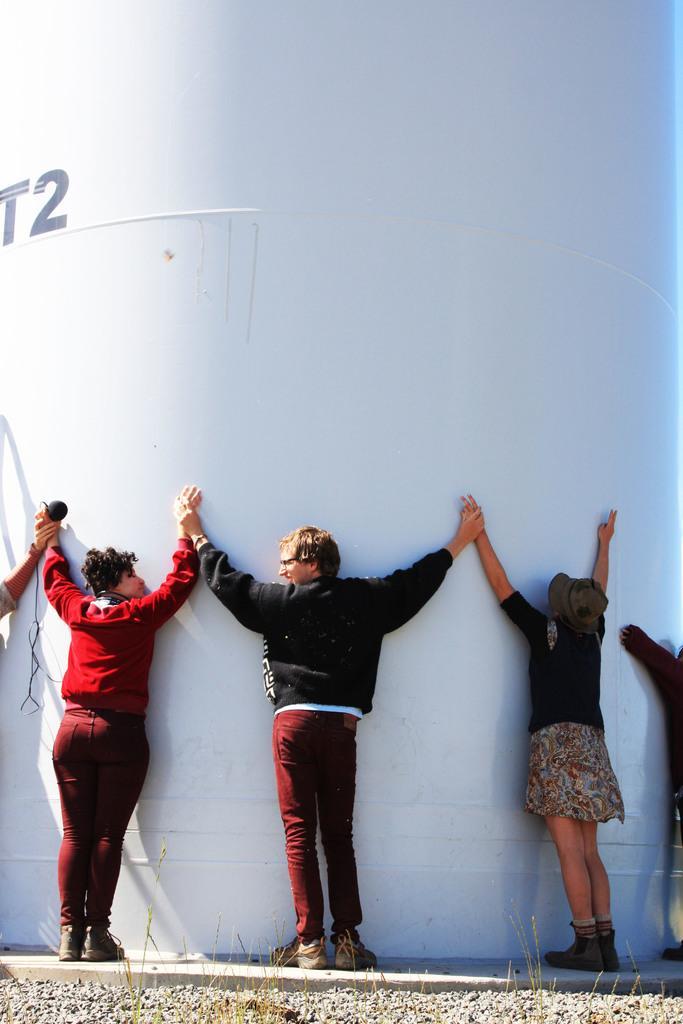Describe this image in one or two sentences. In this image, we can see people wearing clothes and standing in front of the wall. 